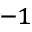<formula> <loc_0><loc_0><loc_500><loc_500>^ { - 1 }</formula> 